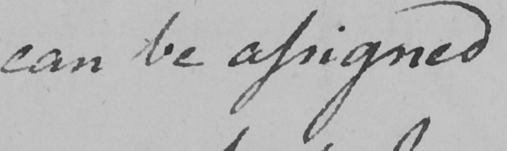Please transcribe the handwritten text in this image. can be assigned 